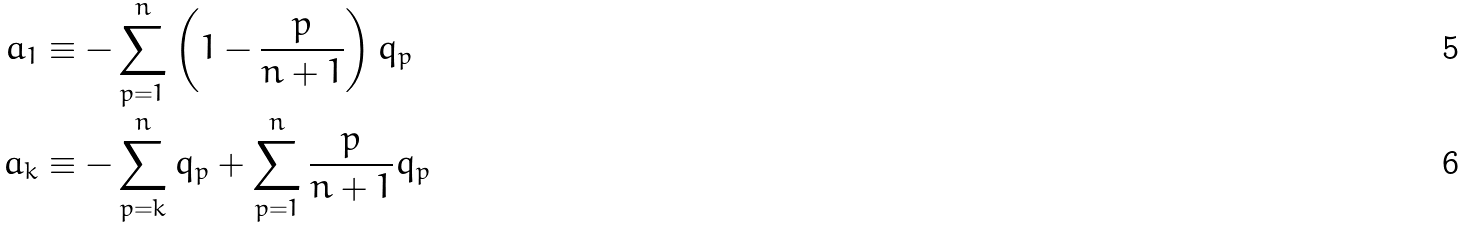<formula> <loc_0><loc_0><loc_500><loc_500>a _ { 1 } & \equiv - \sum _ { p = 1 } ^ { n } \left ( 1 - \frac { p } { n + 1 } \right ) q _ { p } \\ a _ { k } & \equiv - \sum _ { p = k } ^ { n } q _ { p } + \sum _ { p = 1 } ^ { n } \frac { p } { n + 1 } q _ { p }</formula> 